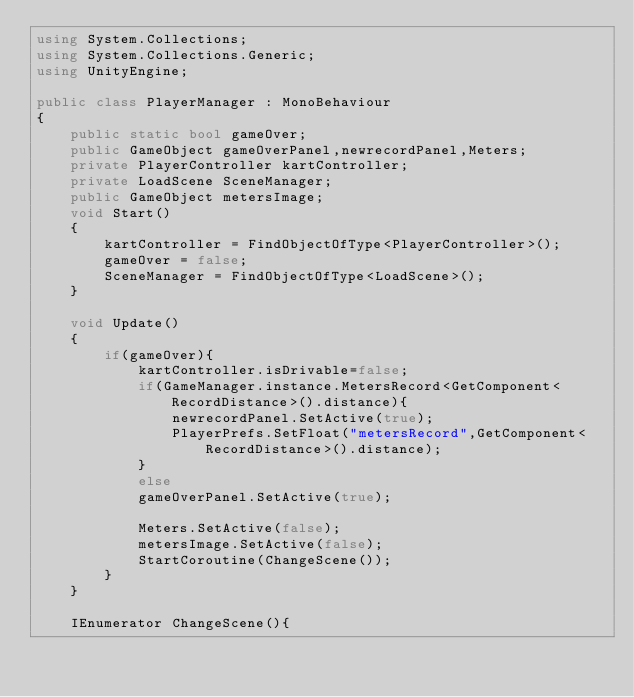<code> <loc_0><loc_0><loc_500><loc_500><_C#_>using System.Collections;
using System.Collections.Generic;
using UnityEngine;

public class PlayerManager : MonoBehaviour
{
    public static bool gameOver;
    public GameObject gameOverPanel,newrecordPanel,Meters;
    private PlayerController kartController;
    private LoadScene SceneManager;
    public GameObject metersImage;
    void Start()
    {
        kartController = FindObjectOfType<PlayerController>();
        gameOver = false;
        SceneManager = FindObjectOfType<LoadScene>();
    }

    void Update()
    {
        if(gameOver){
            kartController.isDrivable=false;
            if(GameManager.instance.MetersRecord<GetComponent<RecordDistance>().distance){
                newrecordPanel.SetActive(true);
                PlayerPrefs.SetFloat("metersRecord",GetComponent<RecordDistance>().distance);
            }
            else
            gameOverPanel.SetActive(true);
        
            Meters.SetActive(false);
            metersImage.SetActive(false);
            StartCoroutine(ChangeScene());
        }
    }

    IEnumerator ChangeScene(){</code> 